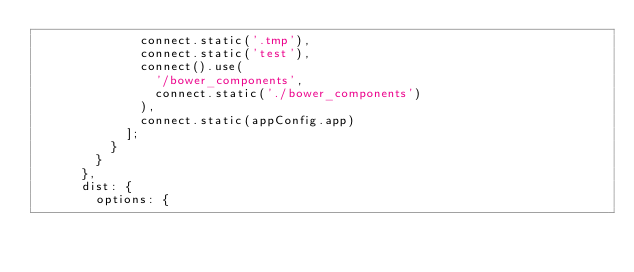Convert code to text. <code><loc_0><loc_0><loc_500><loc_500><_JavaScript_>              connect.static('.tmp'),
              connect.static('test'),
              connect().use(
                '/bower_components',
                connect.static('./bower_components')
              ),
              connect.static(appConfig.app)
            ];
          }
        }
      },
      dist: {
        options: {</code> 